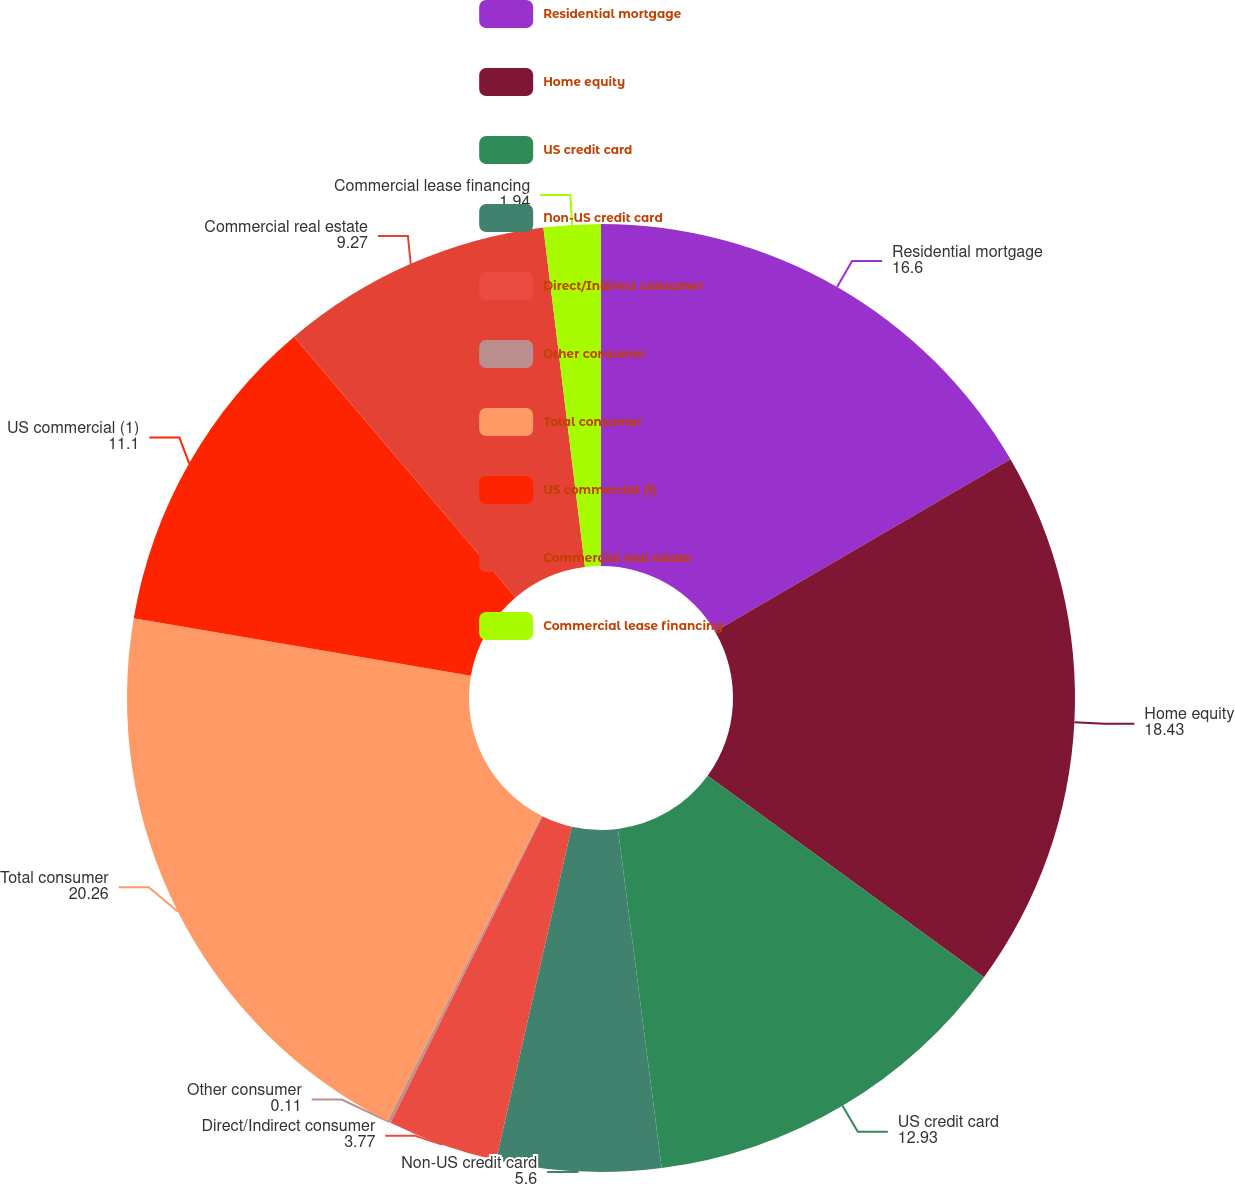<chart> <loc_0><loc_0><loc_500><loc_500><pie_chart><fcel>Residential mortgage<fcel>Home equity<fcel>US credit card<fcel>Non-US credit card<fcel>Direct/Indirect consumer<fcel>Other consumer<fcel>Total consumer<fcel>US commercial (1)<fcel>Commercial real estate<fcel>Commercial lease financing<nl><fcel>16.6%<fcel>18.43%<fcel>12.93%<fcel>5.6%<fcel>3.77%<fcel>0.11%<fcel>20.26%<fcel>11.1%<fcel>9.27%<fcel>1.94%<nl></chart> 